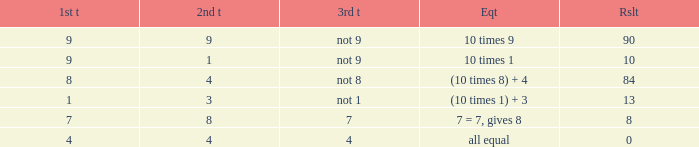If the equation is all equal, what is the 3rd throw? 4.0. 